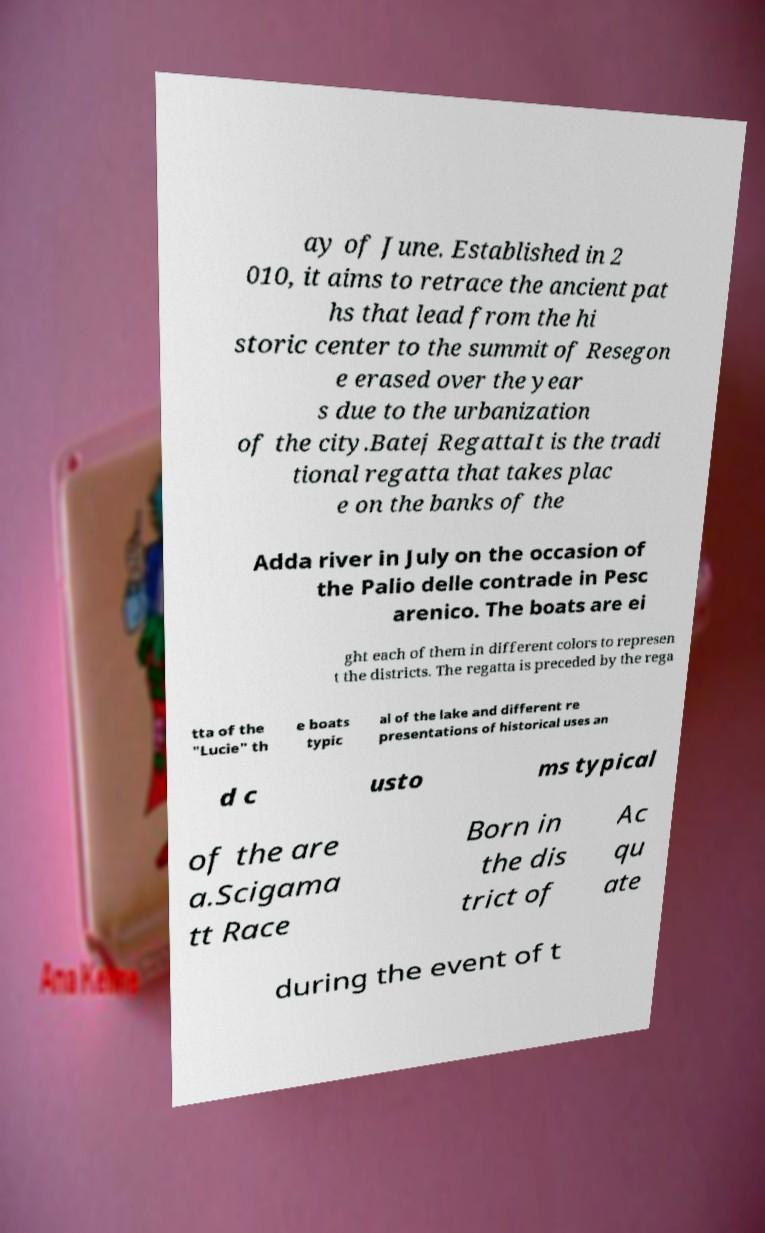What messages or text are displayed in this image? I need them in a readable, typed format. ay of June. Established in 2 010, it aims to retrace the ancient pat hs that lead from the hi storic center to the summit of Resegon e erased over the year s due to the urbanization of the city.Batej RegattaIt is the tradi tional regatta that takes plac e on the banks of the Adda river in July on the occasion of the Palio delle contrade in Pesc arenico. The boats are ei ght each of them in different colors to represen t the districts. The regatta is preceded by the rega tta of the "Lucie" th e boats typic al of the lake and different re presentations of historical uses an d c usto ms typical of the are a.Scigama tt Race Born in the dis trict of Ac qu ate during the event of t 